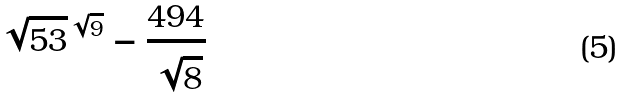<formula> <loc_0><loc_0><loc_500><loc_500>\sqrt { 5 3 } ^ { \sqrt { 9 } } - \frac { 4 9 4 } { \sqrt { 8 } }</formula> 